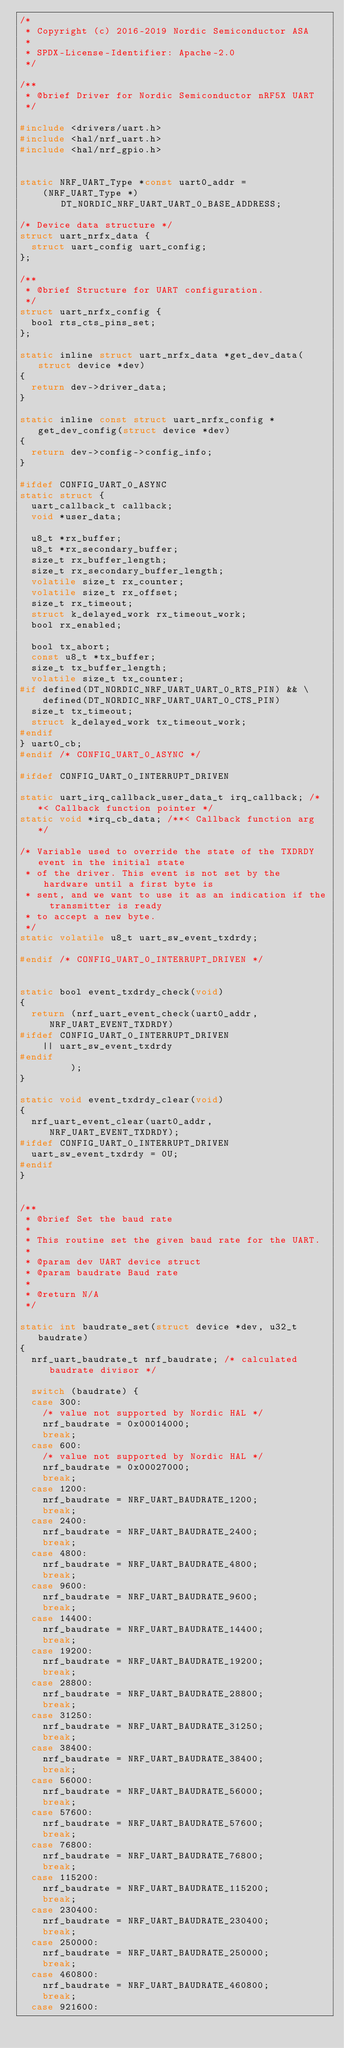Convert code to text. <code><loc_0><loc_0><loc_500><loc_500><_C_>/*
 * Copyright (c) 2016-2019 Nordic Semiconductor ASA
 *
 * SPDX-License-Identifier: Apache-2.0
 */

/**
 * @brief Driver for Nordic Semiconductor nRF5X UART
 */

#include <drivers/uart.h>
#include <hal/nrf_uart.h>
#include <hal/nrf_gpio.h>


static NRF_UART_Type *const uart0_addr =
		(NRF_UART_Type *)DT_NORDIC_NRF_UART_UART_0_BASE_ADDRESS;

/* Device data structure */
struct uart_nrfx_data {
	struct uart_config uart_config;
};

/**
 * @brief Structure for UART configuration.
 */
struct uart_nrfx_config {
	bool rts_cts_pins_set;
};

static inline struct uart_nrfx_data *get_dev_data(struct device *dev)
{
	return dev->driver_data;
}

static inline const struct uart_nrfx_config *get_dev_config(struct device *dev)
{
	return dev->config->config_info;
}

#ifdef CONFIG_UART_0_ASYNC
static struct {
	uart_callback_t callback;
	void *user_data;

	u8_t *rx_buffer;
	u8_t *rx_secondary_buffer;
	size_t rx_buffer_length;
	size_t rx_secondary_buffer_length;
	volatile size_t rx_counter;
	volatile size_t rx_offset;
	size_t rx_timeout;
	struct k_delayed_work rx_timeout_work;
	bool rx_enabled;

	bool tx_abort;
	const u8_t *tx_buffer;
	size_t tx_buffer_length;
	volatile size_t tx_counter;
#if defined(DT_NORDIC_NRF_UART_UART_0_RTS_PIN) && \
		defined(DT_NORDIC_NRF_UART_UART_0_CTS_PIN)
	size_t tx_timeout;
	struct k_delayed_work tx_timeout_work;
#endif
} uart0_cb;
#endif /* CONFIG_UART_0_ASYNC */

#ifdef CONFIG_UART_0_INTERRUPT_DRIVEN

static uart_irq_callback_user_data_t irq_callback; /**< Callback function pointer */
static void *irq_cb_data; /**< Callback function arg */

/* Variable used to override the state of the TXDRDY event in the initial state
 * of the driver. This event is not set by the hardware until a first byte is
 * sent, and we want to use it as an indication if the transmitter is ready
 * to accept a new byte.
 */
static volatile u8_t uart_sw_event_txdrdy;

#endif /* CONFIG_UART_0_INTERRUPT_DRIVEN */


static bool event_txdrdy_check(void)
{
	return (nrf_uart_event_check(uart0_addr, NRF_UART_EVENT_TXDRDY)
#ifdef CONFIG_UART_0_INTERRUPT_DRIVEN
		|| uart_sw_event_txdrdy
#endif
	       );
}

static void event_txdrdy_clear(void)
{
	nrf_uart_event_clear(uart0_addr, NRF_UART_EVENT_TXDRDY);
#ifdef CONFIG_UART_0_INTERRUPT_DRIVEN
	uart_sw_event_txdrdy = 0U;
#endif
}


/**
 * @brief Set the baud rate
 *
 * This routine set the given baud rate for the UART.
 *
 * @param dev UART device struct
 * @param baudrate Baud rate
 *
 * @return N/A
 */

static int baudrate_set(struct device *dev, u32_t baudrate)
{
	nrf_uart_baudrate_t nrf_baudrate; /* calculated baudrate divisor */

	switch (baudrate) {
	case 300:
		/* value not supported by Nordic HAL */
		nrf_baudrate = 0x00014000;
		break;
	case 600:
		/* value not supported by Nordic HAL */
		nrf_baudrate = 0x00027000;
		break;
	case 1200:
		nrf_baudrate = NRF_UART_BAUDRATE_1200;
		break;
	case 2400:
		nrf_baudrate = NRF_UART_BAUDRATE_2400;
		break;
	case 4800:
		nrf_baudrate = NRF_UART_BAUDRATE_4800;
		break;
	case 9600:
		nrf_baudrate = NRF_UART_BAUDRATE_9600;
		break;
	case 14400:
		nrf_baudrate = NRF_UART_BAUDRATE_14400;
		break;
	case 19200:
		nrf_baudrate = NRF_UART_BAUDRATE_19200;
		break;
	case 28800:
		nrf_baudrate = NRF_UART_BAUDRATE_28800;
		break;
	case 31250:
		nrf_baudrate = NRF_UART_BAUDRATE_31250;
		break;
	case 38400:
		nrf_baudrate = NRF_UART_BAUDRATE_38400;
		break;
	case 56000:
		nrf_baudrate = NRF_UART_BAUDRATE_56000;
		break;
	case 57600:
		nrf_baudrate = NRF_UART_BAUDRATE_57600;
		break;
	case 76800:
		nrf_baudrate = NRF_UART_BAUDRATE_76800;
		break;
	case 115200:
		nrf_baudrate = NRF_UART_BAUDRATE_115200;
		break;
	case 230400:
		nrf_baudrate = NRF_UART_BAUDRATE_230400;
		break;
	case 250000:
		nrf_baudrate = NRF_UART_BAUDRATE_250000;
		break;
	case 460800:
		nrf_baudrate = NRF_UART_BAUDRATE_460800;
		break;
	case 921600:</code> 